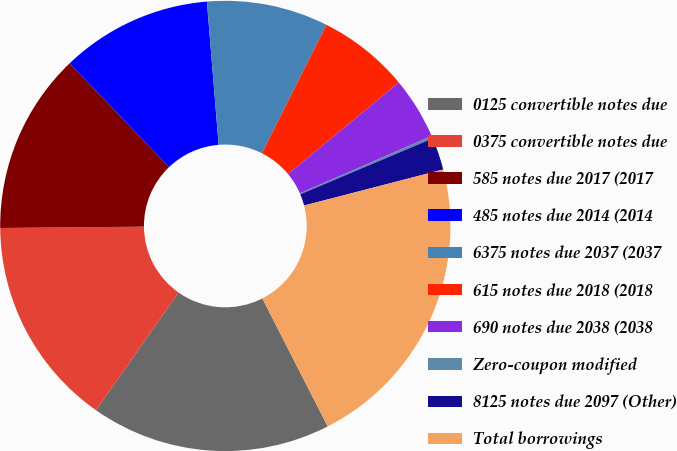Convert chart to OTSL. <chart><loc_0><loc_0><loc_500><loc_500><pie_chart><fcel>0125 convertible notes due<fcel>0375 convertible notes due<fcel>585 notes due 2017 (2017<fcel>485 notes due 2014 (2014<fcel>6375 notes due 2037 (2037<fcel>615 notes due 2018 (2018<fcel>690 notes due 2038 (2038<fcel>Zero-coupon modified<fcel>8125 notes due 2097 (Other)<fcel>Total borrowings<nl><fcel>17.25%<fcel>15.12%<fcel>12.99%<fcel>10.85%<fcel>8.72%<fcel>6.59%<fcel>4.45%<fcel>0.19%<fcel>2.32%<fcel>21.52%<nl></chart> 